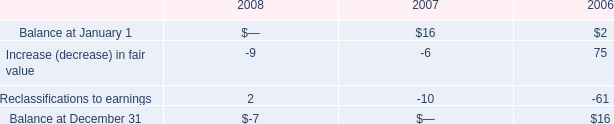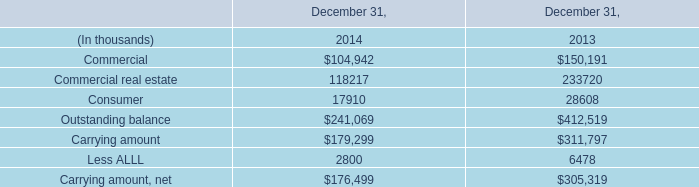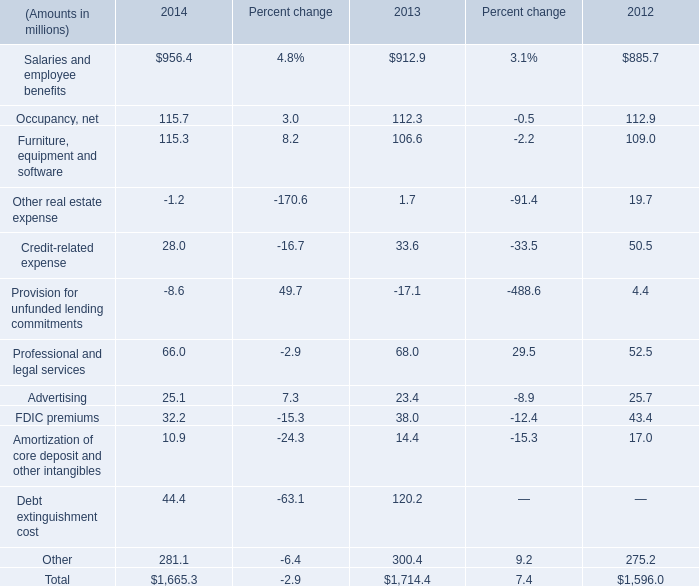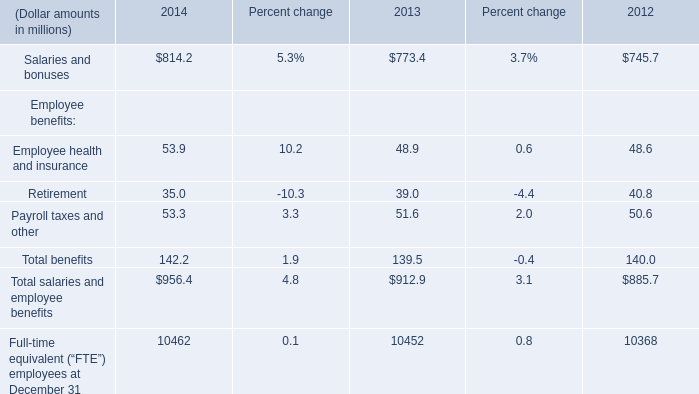What's the total value of all 2014 that are smaller than 0 in 2014? (in million) 
Computations: (-1.2 - 8.6)
Answer: -9.8. 